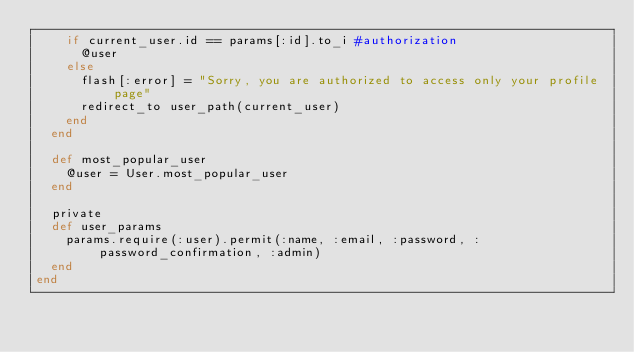Convert code to text. <code><loc_0><loc_0><loc_500><loc_500><_Ruby_>    if current_user.id == params[:id].to_i #authorization
      @user
    else
      flash[:error] = "Sorry, you are authorized to access only your profile page"
      redirect_to user_path(current_user)
    end
  end

  def most_popular_user
    @user = User.most_popular_user
  end

  private
  def user_params
    params.require(:user).permit(:name, :email, :password, :password_confirmation, :admin)
  end
end</code> 